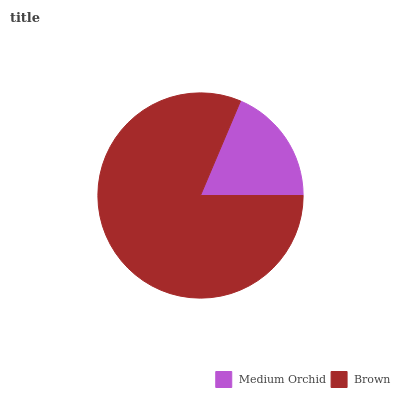Is Medium Orchid the minimum?
Answer yes or no. Yes. Is Brown the maximum?
Answer yes or no. Yes. Is Brown the minimum?
Answer yes or no. No. Is Brown greater than Medium Orchid?
Answer yes or no. Yes. Is Medium Orchid less than Brown?
Answer yes or no. Yes. Is Medium Orchid greater than Brown?
Answer yes or no. No. Is Brown less than Medium Orchid?
Answer yes or no. No. Is Brown the high median?
Answer yes or no. Yes. Is Medium Orchid the low median?
Answer yes or no. Yes. Is Medium Orchid the high median?
Answer yes or no. No. Is Brown the low median?
Answer yes or no. No. 